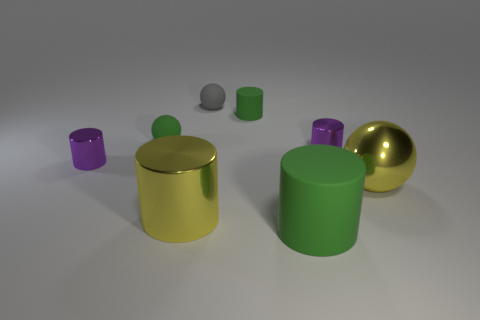Subtract all tiny metallic cylinders. How many cylinders are left? 3 Subtract all green cylinders. How many cylinders are left? 3 Subtract 1 balls. How many balls are left? 2 Add 2 tiny purple cylinders. How many objects exist? 10 Subtract all balls. How many objects are left? 5 Subtract all yellow cylinders. Subtract all green balls. How many cylinders are left? 4 Subtract all purple spheres. How many green cylinders are left? 2 Subtract all small matte cylinders. Subtract all small metal objects. How many objects are left? 5 Add 2 tiny green spheres. How many tiny green spheres are left? 3 Add 1 gray balls. How many gray balls exist? 2 